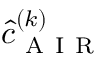Convert formula to latex. <formula><loc_0><loc_0><loc_500><loc_500>\hat { c } _ { A I R } ^ { ( k ) }</formula> 